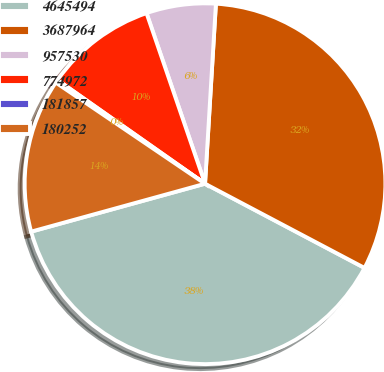Convert chart. <chart><loc_0><loc_0><loc_500><loc_500><pie_chart><fcel>4645494<fcel>3687964<fcel>957530<fcel>774972<fcel>181857<fcel>180252<nl><fcel>37.99%<fcel>31.77%<fcel>6.22%<fcel>9.99%<fcel>0.27%<fcel>13.76%<nl></chart> 